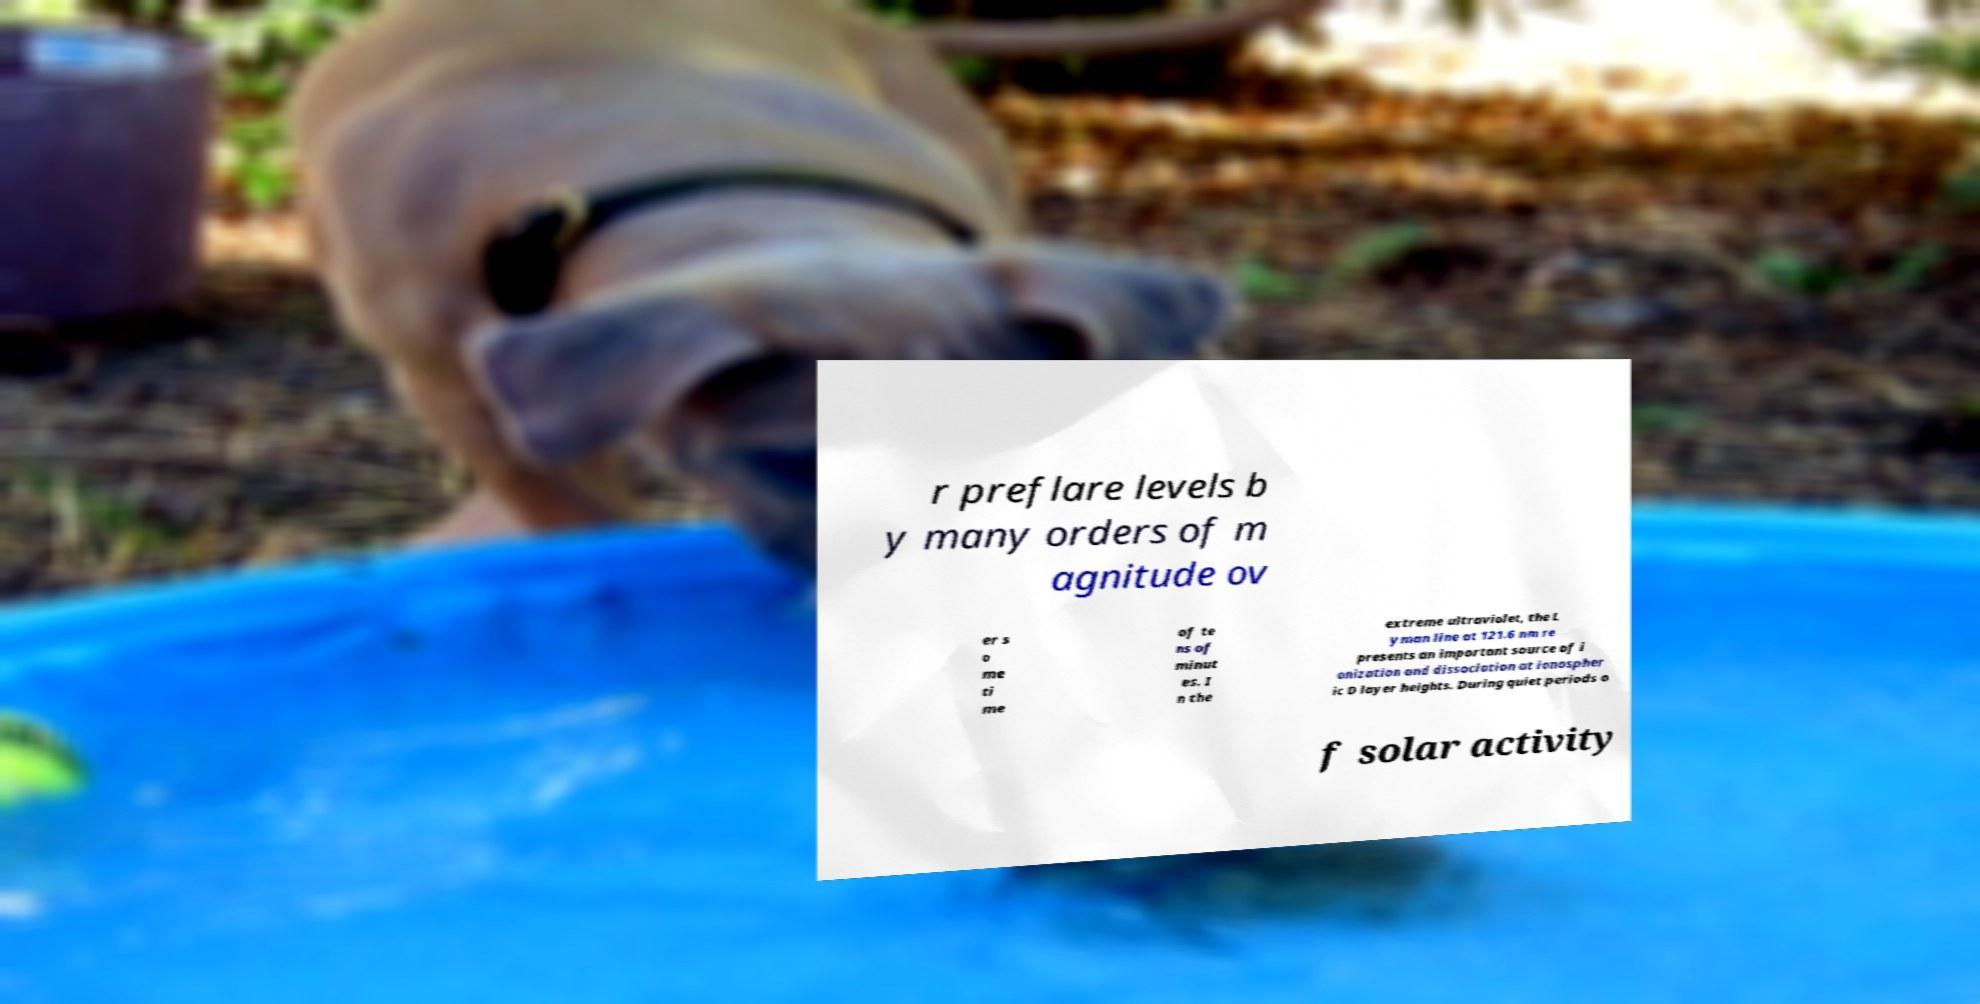Could you extract and type out the text from this image? r preflare levels b y many orders of m agnitude ov er s o me ti me of te ns of minut es. I n the extreme ultraviolet, the L yman line at 121.6 nm re presents an important source of i onization and dissociation at ionospher ic D layer heights. During quiet periods o f solar activity 